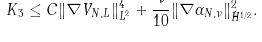Convert formula to latex. <formula><loc_0><loc_0><loc_500><loc_500>K _ { 3 } \leq C \| \nabla V _ { N , L } \| _ { L ^ { 2 } } ^ { 4 } + \frac { \nu } { 1 0 } \| \nabla \alpha _ { N , \nu } \| _ { \dot { H } ^ { 1 / 2 } } ^ { 2 } . \\ \\</formula> 